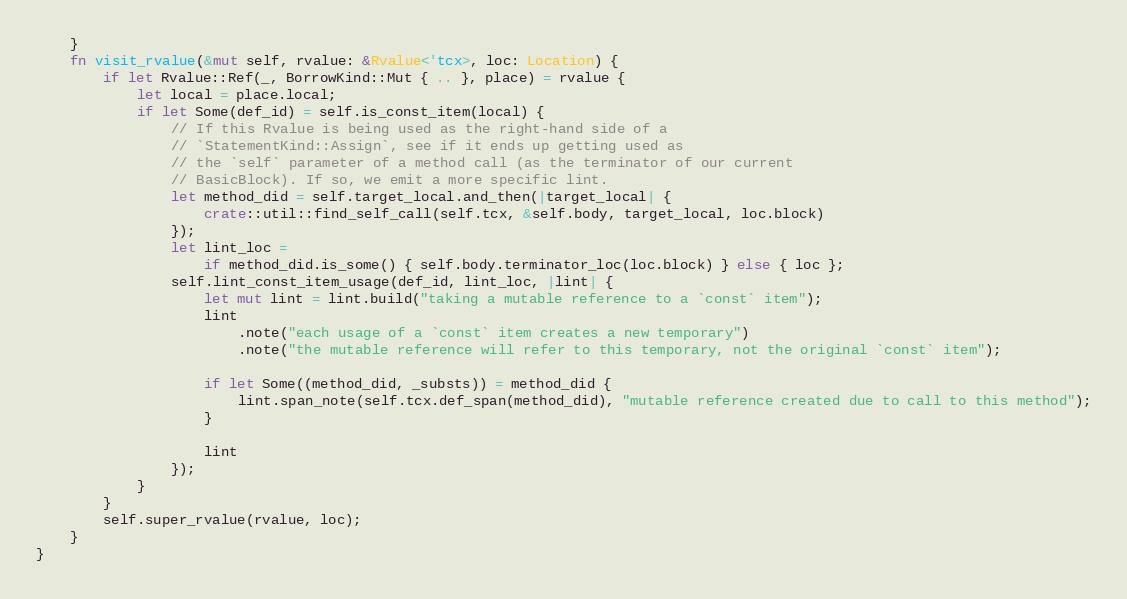Convert code to text. <code><loc_0><loc_0><loc_500><loc_500><_Rust_>    }
    fn visit_rvalue(&mut self, rvalue: &Rvalue<'tcx>, loc: Location) {
        if let Rvalue::Ref(_, BorrowKind::Mut { .. }, place) = rvalue {
            let local = place.local;
            if let Some(def_id) = self.is_const_item(local) {
                // If this Rvalue is being used as the right-hand side of a
                // `StatementKind::Assign`, see if it ends up getting used as
                // the `self` parameter of a method call (as the terminator of our current
                // BasicBlock). If so, we emit a more specific lint.
                let method_did = self.target_local.and_then(|target_local| {
                    crate::util::find_self_call(self.tcx, &self.body, target_local, loc.block)
                });
                let lint_loc =
                    if method_did.is_some() { self.body.terminator_loc(loc.block) } else { loc };
                self.lint_const_item_usage(def_id, lint_loc, |lint| {
                    let mut lint = lint.build("taking a mutable reference to a `const` item");
                    lint
                        .note("each usage of a `const` item creates a new temporary")
                        .note("the mutable reference will refer to this temporary, not the original `const` item");

                    if let Some((method_did, _substs)) = method_did {
                        lint.span_note(self.tcx.def_span(method_did), "mutable reference created due to call to this method");
                    }

                    lint
                });
            }
        }
        self.super_rvalue(rvalue, loc);
    }
}
</code> 